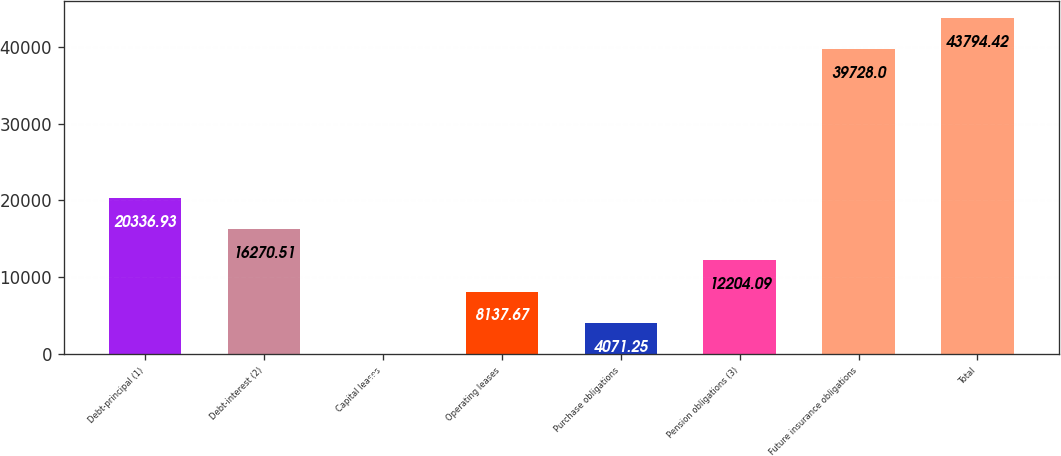Convert chart. <chart><loc_0><loc_0><loc_500><loc_500><bar_chart><fcel>Debt-principal (1)<fcel>Debt-interest (2)<fcel>Capital leases<fcel>Operating leases<fcel>Purchase obligations<fcel>Pension obligations (3)<fcel>Future insurance obligations<fcel>Total<nl><fcel>20336.9<fcel>16270.5<fcel>4.83<fcel>8137.67<fcel>4071.25<fcel>12204.1<fcel>39728<fcel>43794.4<nl></chart> 